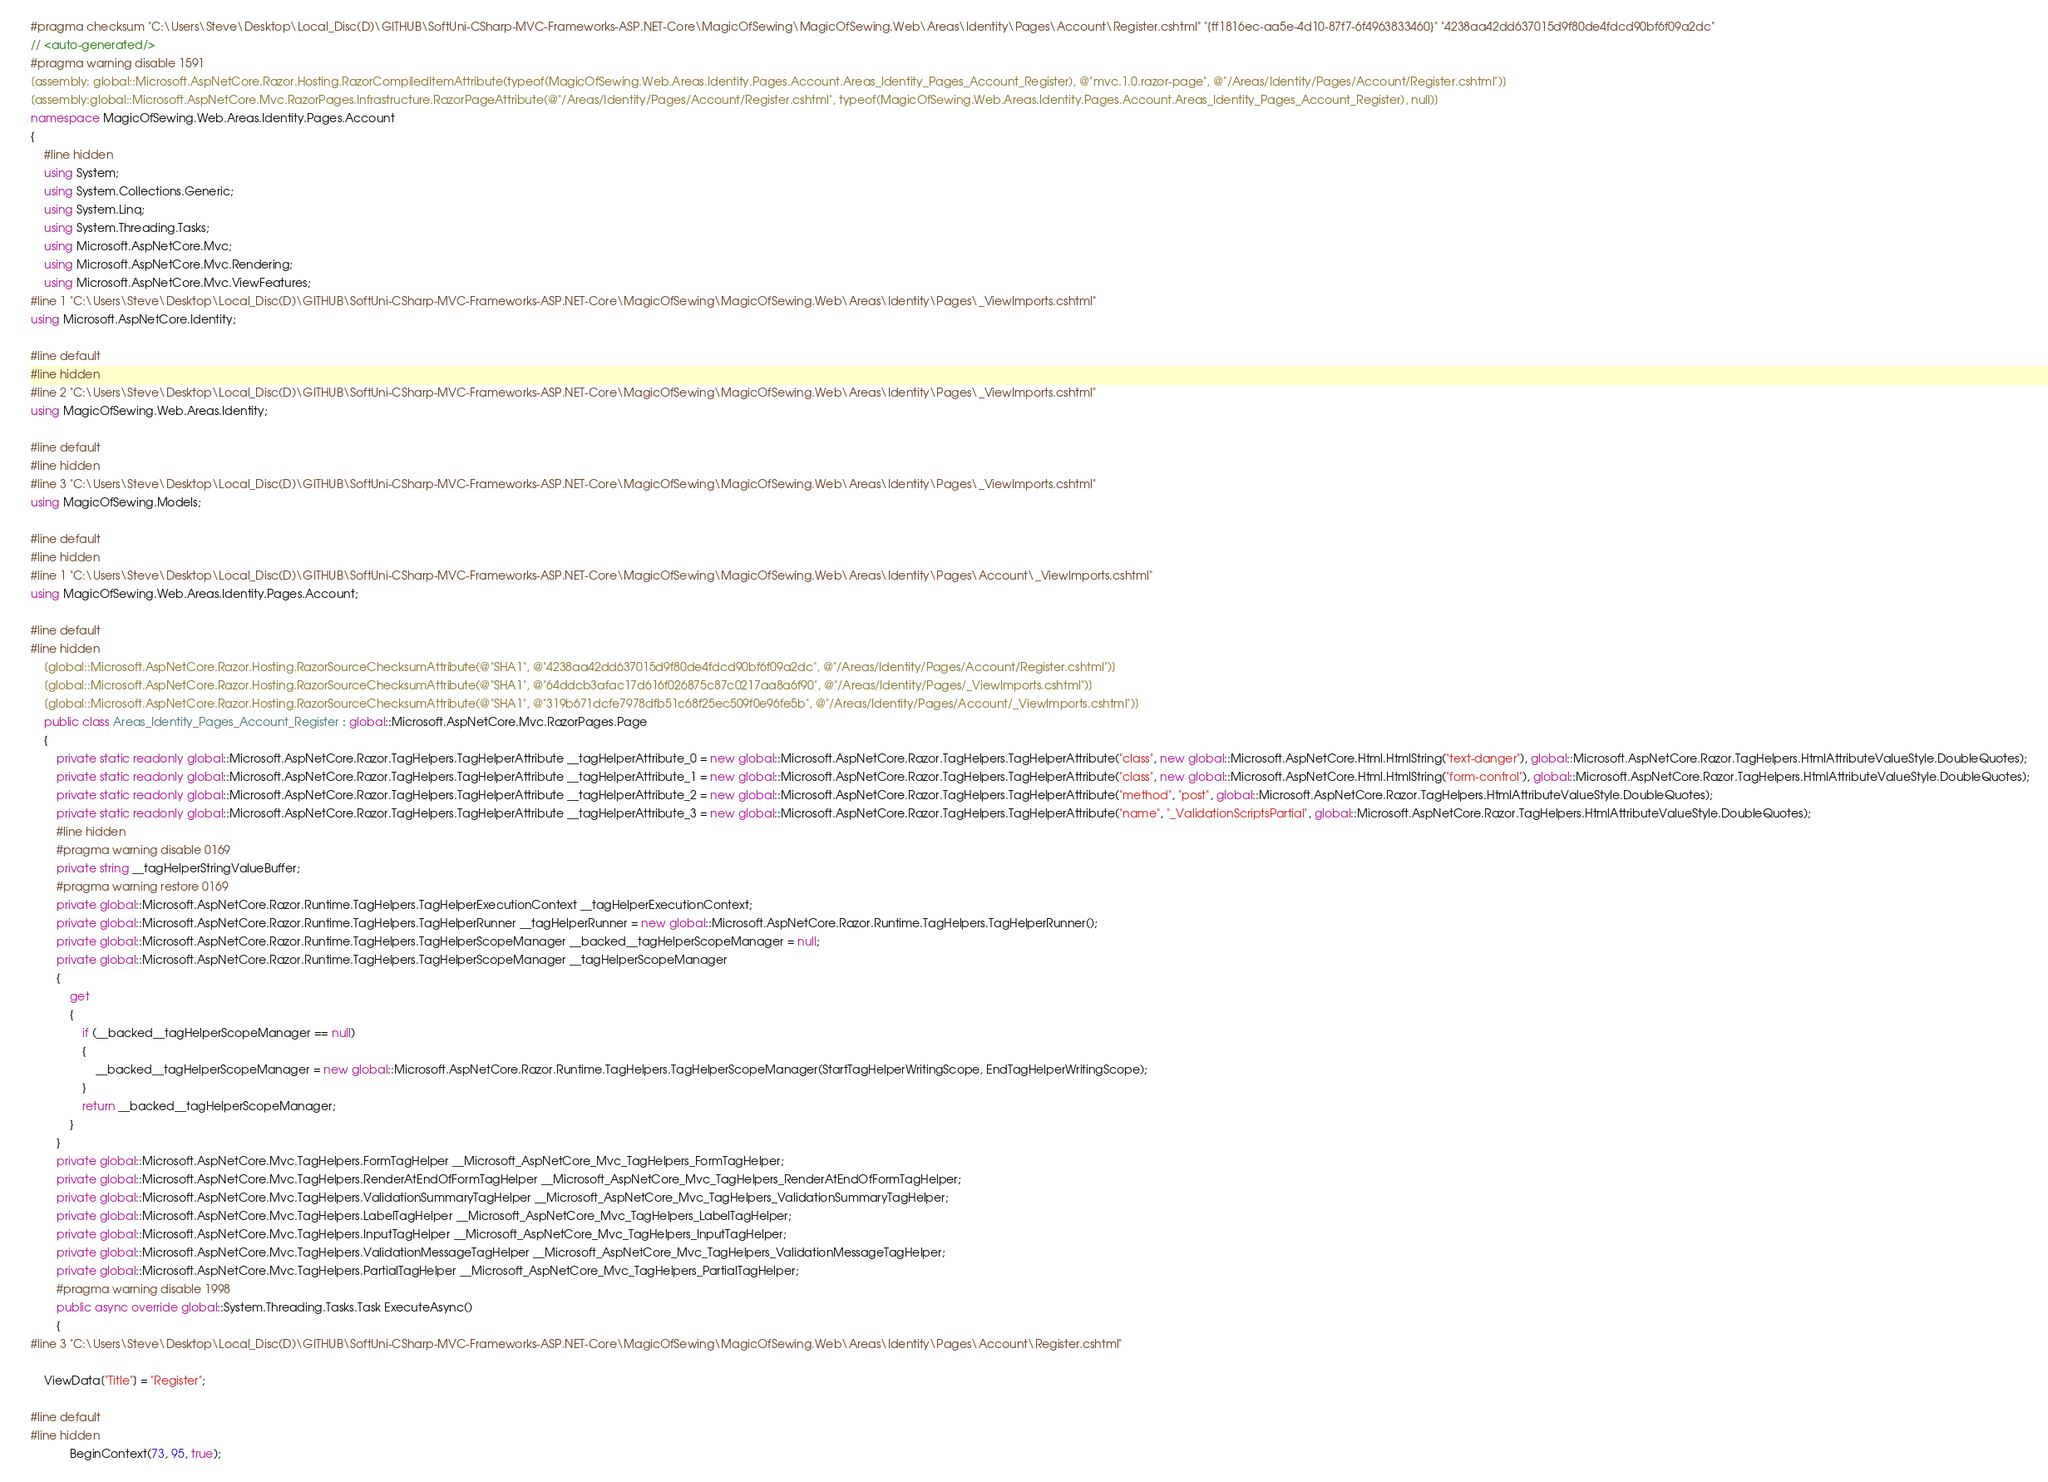<code> <loc_0><loc_0><loc_500><loc_500><_C#_>#pragma checksum "C:\Users\Steve\Desktop\Local_Disc(D)\GITHUB\SoftUni-CSharp-MVC-Frameworks-ASP.NET-Core\MagicOfSewing\MagicOfSewing.Web\Areas\Identity\Pages\Account\Register.cshtml" "{ff1816ec-aa5e-4d10-87f7-6f4963833460}" "4238aa42dd637015d9f80de4fdcd90bf6f09a2dc"
// <auto-generated/>
#pragma warning disable 1591
[assembly: global::Microsoft.AspNetCore.Razor.Hosting.RazorCompiledItemAttribute(typeof(MagicOfSewing.Web.Areas.Identity.Pages.Account.Areas_Identity_Pages_Account_Register), @"mvc.1.0.razor-page", @"/Areas/Identity/Pages/Account/Register.cshtml")]
[assembly:global::Microsoft.AspNetCore.Mvc.RazorPages.Infrastructure.RazorPageAttribute(@"/Areas/Identity/Pages/Account/Register.cshtml", typeof(MagicOfSewing.Web.Areas.Identity.Pages.Account.Areas_Identity_Pages_Account_Register), null)]
namespace MagicOfSewing.Web.Areas.Identity.Pages.Account
{
    #line hidden
    using System;
    using System.Collections.Generic;
    using System.Linq;
    using System.Threading.Tasks;
    using Microsoft.AspNetCore.Mvc;
    using Microsoft.AspNetCore.Mvc.Rendering;
    using Microsoft.AspNetCore.Mvc.ViewFeatures;
#line 1 "C:\Users\Steve\Desktop\Local_Disc(D)\GITHUB\SoftUni-CSharp-MVC-Frameworks-ASP.NET-Core\MagicOfSewing\MagicOfSewing.Web\Areas\Identity\Pages\_ViewImports.cshtml"
using Microsoft.AspNetCore.Identity;

#line default
#line hidden
#line 2 "C:\Users\Steve\Desktop\Local_Disc(D)\GITHUB\SoftUni-CSharp-MVC-Frameworks-ASP.NET-Core\MagicOfSewing\MagicOfSewing.Web\Areas\Identity\Pages\_ViewImports.cshtml"
using MagicOfSewing.Web.Areas.Identity;

#line default
#line hidden
#line 3 "C:\Users\Steve\Desktop\Local_Disc(D)\GITHUB\SoftUni-CSharp-MVC-Frameworks-ASP.NET-Core\MagicOfSewing\MagicOfSewing.Web\Areas\Identity\Pages\_ViewImports.cshtml"
using MagicOfSewing.Models;

#line default
#line hidden
#line 1 "C:\Users\Steve\Desktop\Local_Disc(D)\GITHUB\SoftUni-CSharp-MVC-Frameworks-ASP.NET-Core\MagicOfSewing\MagicOfSewing.Web\Areas\Identity\Pages\Account\_ViewImports.cshtml"
using MagicOfSewing.Web.Areas.Identity.Pages.Account;

#line default
#line hidden
    [global::Microsoft.AspNetCore.Razor.Hosting.RazorSourceChecksumAttribute(@"SHA1", @"4238aa42dd637015d9f80de4fdcd90bf6f09a2dc", @"/Areas/Identity/Pages/Account/Register.cshtml")]
    [global::Microsoft.AspNetCore.Razor.Hosting.RazorSourceChecksumAttribute(@"SHA1", @"64ddcb3afac17d616f026875c87c0217aa8a6f90", @"/Areas/Identity/Pages/_ViewImports.cshtml")]
    [global::Microsoft.AspNetCore.Razor.Hosting.RazorSourceChecksumAttribute(@"SHA1", @"319b671dcfe7978dfb51c68f25ec509f0e96fe5b", @"/Areas/Identity/Pages/Account/_ViewImports.cshtml")]
    public class Areas_Identity_Pages_Account_Register : global::Microsoft.AspNetCore.Mvc.RazorPages.Page
    {
        private static readonly global::Microsoft.AspNetCore.Razor.TagHelpers.TagHelperAttribute __tagHelperAttribute_0 = new global::Microsoft.AspNetCore.Razor.TagHelpers.TagHelperAttribute("class", new global::Microsoft.AspNetCore.Html.HtmlString("text-danger"), global::Microsoft.AspNetCore.Razor.TagHelpers.HtmlAttributeValueStyle.DoubleQuotes);
        private static readonly global::Microsoft.AspNetCore.Razor.TagHelpers.TagHelperAttribute __tagHelperAttribute_1 = new global::Microsoft.AspNetCore.Razor.TagHelpers.TagHelperAttribute("class", new global::Microsoft.AspNetCore.Html.HtmlString("form-control"), global::Microsoft.AspNetCore.Razor.TagHelpers.HtmlAttributeValueStyle.DoubleQuotes);
        private static readonly global::Microsoft.AspNetCore.Razor.TagHelpers.TagHelperAttribute __tagHelperAttribute_2 = new global::Microsoft.AspNetCore.Razor.TagHelpers.TagHelperAttribute("method", "post", global::Microsoft.AspNetCore.Razor.TagHelpers.HtmlAttributeValueStyle.DoubleQuotes);
        private static readonly global::Microsoft.AspNetCore.Razor.TagHelpers.TagHelperAttribute __tagHelperAttribute_3 = new global::Microsoft.AspNetCore.Razor.TagHelpers.TagHelperAttribute("name", "_ValidationScriptsPartial", global::Microsoft.AspNetCore.Razor.TagHelpers.HtmlAttributeValueStyle.DoubleQuotes);
        #line hidden
        #pragma warning disable 0169
        private string __tagHelperStringValueBuffer;
        #pragma warning restore 0169
        private global::Microsoft.AspNetCore.Razor.Runtime.TagHelpers.TagHelperExecutionContext __tagHelperExecutionContext;
        private global::Microsoft.AspNetCore.Razor.Runtime.TagHelpers.TagHelperRunner __tagHelperRunner = new global::Microsoft.AspNetCore.Razor.Runtime.TagHelpers.TagHelperRunner();
        private global::Microsoft.AspNetCore.Razor.Runtime.TagHelpers.TagHelperScopeManager __backed__tagHelperScopeManager = null;
        private global::Microsoft.AspNetCore.Razor.Runtime.TagHelpers.TagHelperScopeManager __tagHelperScopeManager
        {
            get
            {
                if (__backed__tagHelperScopeManager == null)
                {
                    __backed__tagHelperScopeManager = new global::Microsoft.AspNetCore.Razor.Runtime.TagHelpers.TagHelperScopeManager(StartTagHelperWritingScope, EndTagHelperWritingScope);
                }
                return __backed__tagHelperScopeManager;
            }
        }
        private global::Microsoft.AspNetCore.Mvc.TagHelpers.FormTagHelper __Microsoft_AspNetCore_Mvc_TagHelpers_FormTagHelper;
        private global::Microsoft.AspNetCore.Mvc.TagHelpers.RenderAtEndOfFormTagHelper __Microsoft_AspNetCore_Mvc_TagHelpers_RenderAtEndOfFormTagHelper;
        private global::Microsoft.AspNetCore.Mvc.TagHelpers.ValidationSummaryTagHelper __Microsoft_AspNetCore_Mvc_TagHelpers_ValidationSummaryTagHelper;
        private global::Microsoft.AspNetCore.Mvc.TagHelpers.LabelTagHelper __Microsoft_AspNetCore_Mvc_TagHelpers_LabelTagHelper;
        private global::Microsoft.AspNetCore.Mvc.TagHelpers.InputTagHelper __Microsoft_AspNetCore_Mvc_TagHelpers_InputTagHelper;
        private global::Microsoft.AspNetCore.Mvc.TagHelpers.ValidationMessageTagHelper __Microsoft_AspNetCore_Mvc_TagHelpers_ValidationMessageTagHelper;
        private global::Microsoft.AspNetCore.Mvc.TagHelpers.PartialTagHelper __Microsoft_AspNetCore_Mvc_TagHelpers_PartialTagHelper;
        #pragma warning disable 1998
        public async override global::System.Threading.Tasks.Task ExecuteAsync()
        {
#line 3 "C:\Users\Steve\Desktop\Local_Disc(D)\GITHUB\SoftUni-CSharp-MVC-Frameworks-ASP.NET-Core\MagicOfSewing\MagicOfSewing.Web\Areas\Identity\Pages\Account\Register.cshtml"
  
    ViewData["Title"] = "Register";

#line default
#line hidden
            BeginContext(73, 95, true);</code> 